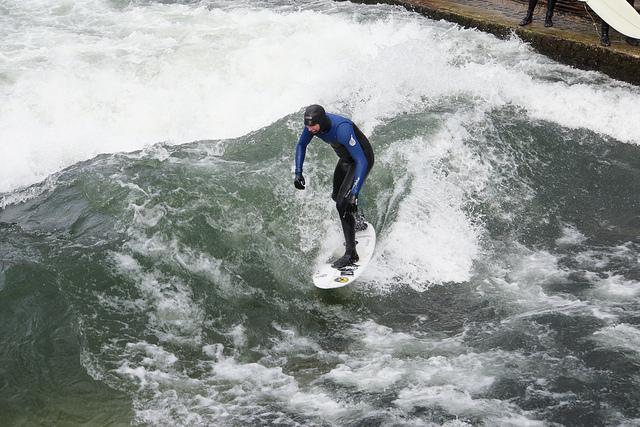Is this near or far from the shore?
Give a very brief answer. Near. Are the waters calm?
Concise answer only. No. What color is the wetsuit?
Short answer required. Blue and black. Is the surfer dressed in a swimsuit?
Concise answer only. No. Is that a large surfboard?
Give a very brief answer. No. Male or female?
Short answer required. Male. 